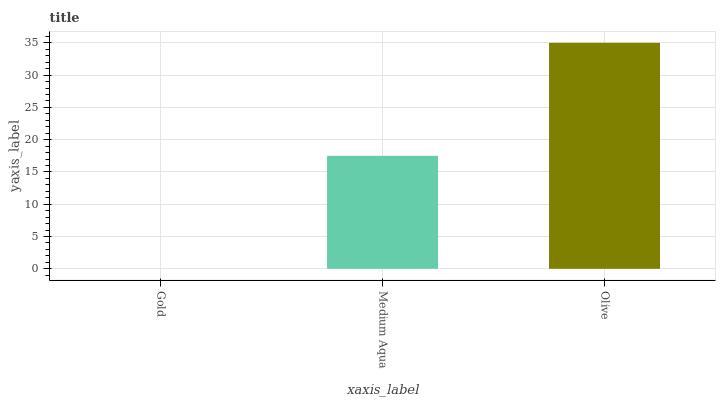Is Medium Aqua the minimum?
Answer yes or no. No. Is Medium Aqua the maximum?
Answer yes or no. No. Is Medium Aqua greater than Gold?
Answer yes or no. Yes. Is Gold less than Medium Aqua?
Answer yes or no. Yes. Is Gold greater than Medium Aqua?
Answer yes or no. No. Is Medium Aqua less than Gold?
Answer yes or no. No. Is Medium Aqua the high median?
Answer yes or no. Yes. Is Medium Aqua the low median?
Answer yes or no. Yes. Is Gold the high median?
Answer yes or no. No. Is Gold the low median?
Answer yes or no. No. 